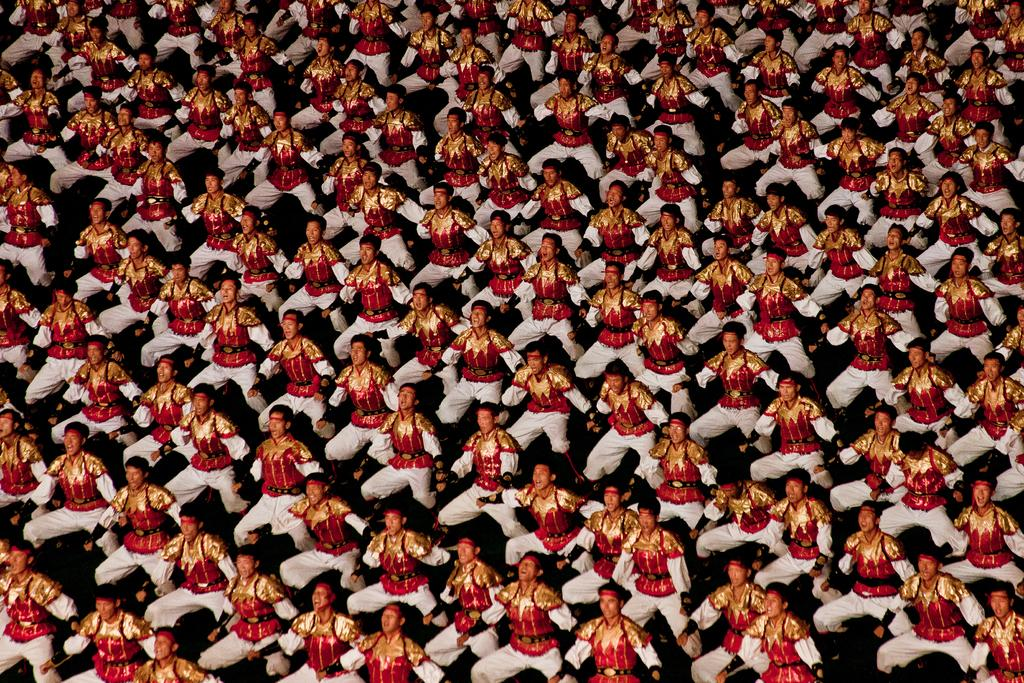How many men are in the image? There are multiple men in the image. What are the men wearing? The men are wearing the same dress. What are the men doing in the image? The men are dancing. What type of space is visible in the background of the image? There is no space visible in the background of the image; it is focused on the men dancing. What type of canvas is being used by the men to dance on? There is no canvas present in the image; the men are dancing on a solid surface. 